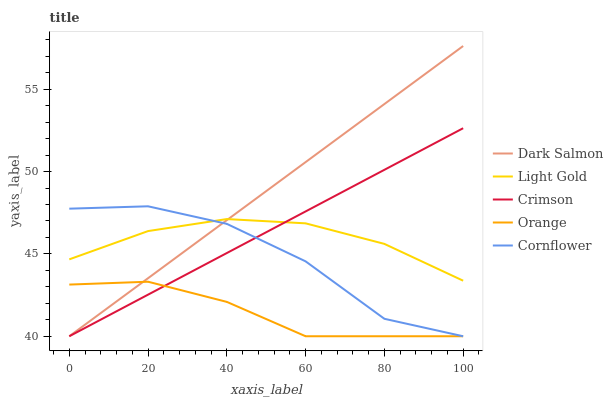Does Orange have the minimum area under the curve?
Answer yes or no. Yes. Does Dark Salmon have the maximum area under the curve?
Answer yes or no. Yes. Does Light Gold have the minimum area under the curve?
Answer yes or no. No. Does Light Gold have the maximum area under the curve?
Answer yes or no. No. Is Crimson the smoothest?
Answer yes or no. Yes. Is Cornflower the roughest?
Answer yes or no. Yes. Is Orange the smoothest?
Answer yes or no. No. Is Orange the roughest?
Answer yes or no. No. Does Crimson have the lowest value?
Answer yes or no. Yes. Does Light Gold have the lowest value?
Answer yes or no. No. Does Dark Salmon have the highest value?
Answer yes or no. Yes. Does Light Gold have the highest value?
Answer yes or no. No. Is Orange less than Light Gold?
Answer yes or no. Yes. Is Light Gold greater than Orange?
Answer yes or no. Yes. Does Orange intersect Dark Salmon?
Answer yes or no. Yes. Is Orange less than Dark Salmon?
Answer yes or no. No. Is Orange greater than Dark Salmon?
Answer yes or no. No. Does Orange intersect Light Gold?
Answer yes or no. No. 